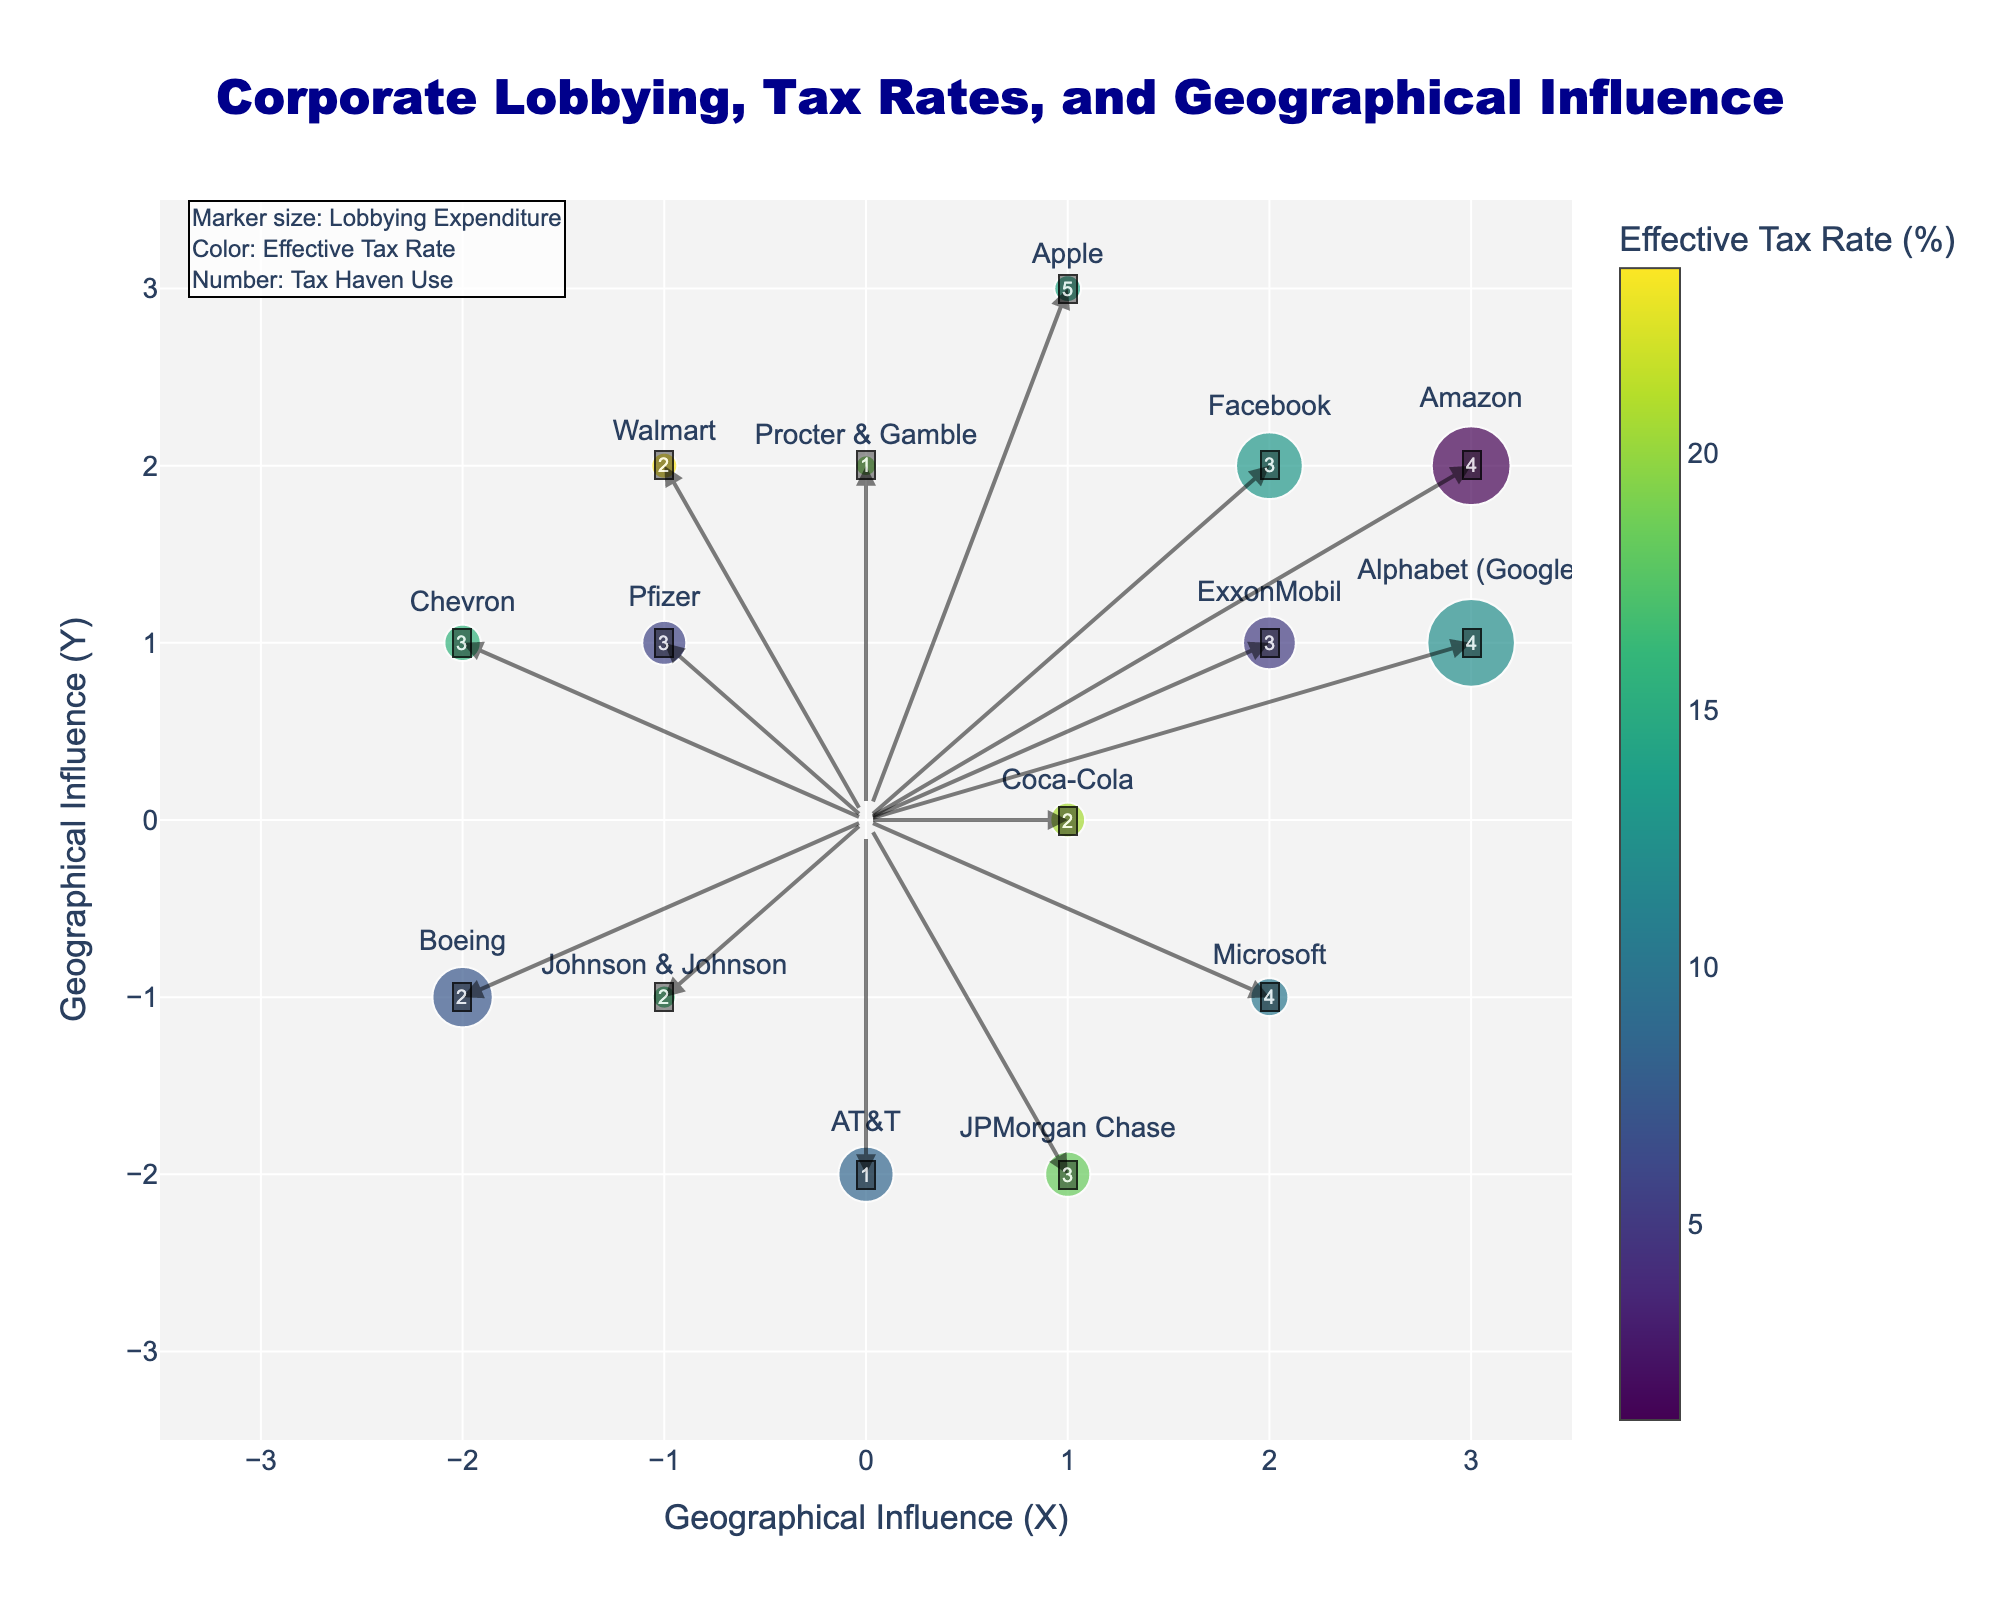What is the title of the figure? The title is at the top of the figure, centered and in dark blue color. It reads "Corporate Lobbying, Tax Rates, and Geographical Influence".
Answer: Corporate Lobbying, Tax Rates, and Geographical Influence Which company has the highest lobbying expenditure? By examining the size of the markers, the largest marker corresponds to Alphabet (Google) with a lobbying expenditure of $21.9 million.
Answer: Alphabet (Google) How many companies have an effective tax rate below 10%? The color bar indicates that lower tax rates are darker. By matching the colors and using the hover information, there are four companies with a tax rate below 10%. These are ExxonMobil, Amazon, Facebook, and Boeing.
Answer: 4 Which company has a geographical influence in the second quadrant (negative X, positive Y)? In the second quadrant, where Geographical Influence X is negative and Y is positive, we find Chevron at (-2, 1).
Answer: Chevron What is the effective tax rate of Microsoft and how does it compare to Amazon's? By hovering over Microsoft, we see an effective tax rate of 10.2%. Amazon has a much lower effective tax rate of 1.2%. Microsoft’s rate is significantly higher.
Answer: Microsoft: 10.2%, higher than Amazon Which company is utilizing the highest level of tax haven use, and where is it located in terms of geographical influence? Apple has the highest tax haven use value of 5. By checking the position, Apple is located at (1, 3) on the Geographical Influence plane.
Answer: Apple, (1, 3) What is the relationship between lobbying expenditure and effective tax rate for ExxonMobil? For ExxonMobil, the figure shows a lobbying expenditure of $13.2 million and an effective tax rate of 5.1%. Despite significant lobbying expenditure, the tax rate remains quite low.
Answer: High lobbying, low tax rate How does the geographical influence of Walmart compare to that of Pfizer? Walmart's geographical influence is (-1, 2) while Pfizer's is (-1, 1). Walmart has a similar X influence but greater positive Y influence compared to Pfizer.
Answer: Walmart: (-1, 2), Pfizer: (-1, 1), greater Y influence for Walmart 